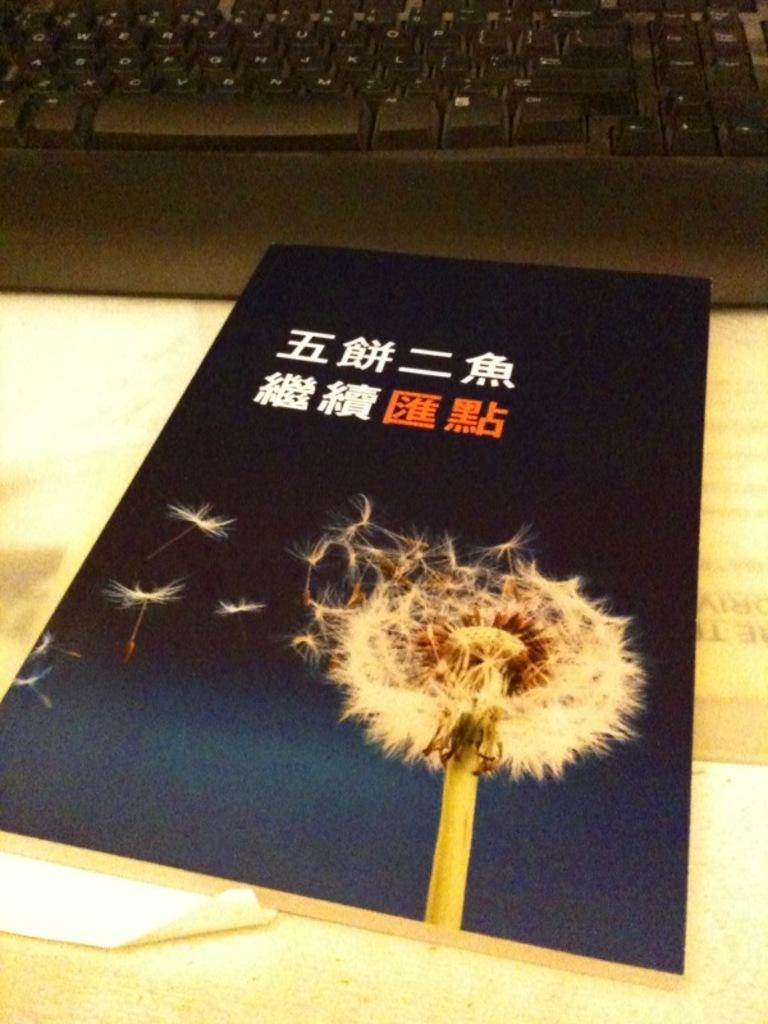What is depicted on the poster in the image? The poster features a flower. Where is the poster located in the image? The poster is on a table. What other object can be seen on the table in the image? There is a keyboard visible in the image. What type of locket is hanging from the flower on the poster? There is no locket present on the flower in the poster; it only features a flower. 